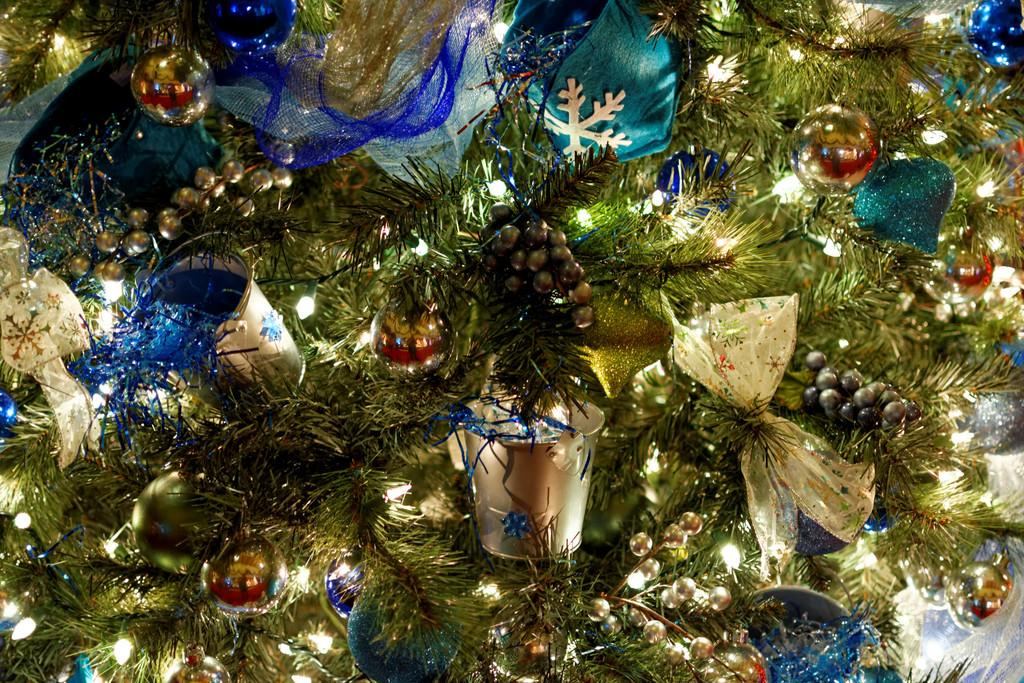What is the main object in the image? There is a Christmas tree in the image. What can be seen on the Christmas tree? The Christmas tree has lights and decorative items. How many chickens are sitting on the Christmas tree in the image? There are no chickens present on the Christmas tree in the image. 